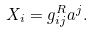Convert formula to latex. <formula><loc_0><loc_0><loc_500><loc_500>X _ { i } = g _ { i j } ^ { R } a ^ { j } .</formula> 